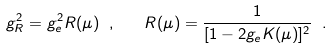Convert formula to latex. <formula><loc_0><loc_0><loc_500><loc_500>g _ { R } ^ { 2 } = g _ { e } ^ { 2 } R ( \mu ) \ , \quad R ( \mu ) = \frac { 1 } { [ 1 - 2 g _ { e } K ( \mu ) ] ^ { 2 } } \ .</formula> 